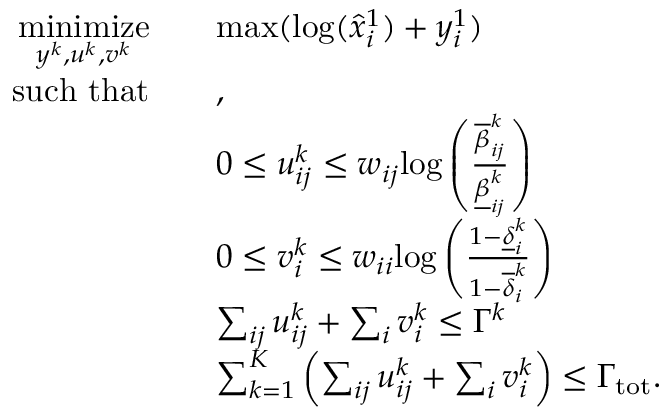<formula> <loc_0><loc_0><loc_500><loc_500>\begin{array} { r l } { \underset { y ^ { k } , u ^ { k } , v ^ { k } } { \min i m i z e } } & { \quad \max ( \log ( \hat { x } _ { i } ^ { 1 } ) + y _ { i } ^ { 1 } ) } \\ { s u c h t h a t } & { \quad , \quad } \\ & { \quad 0 \leq u _ { i j } ^ { k } \leq w _ { i j } \log \left ( \frac { \overline { \beta } _ { i j } ^ { k } } { \underline { \beta } _ { i j } ^ { k } } \right ) } \\ & { \quad 0 \leq v _ { i } ^ { k } \leq w _ { i i } \log \left ( \frac { 1 - \underline { \delta } _ { i } ^ { k } } { 1 - \overline { \delta } _ { i } ^ { k } } \right ) } \\ & { \quad \sum _ { i j } u _ { i j } ^ { k } + \sum _ { i } v _ { i } ^ { k } \leq \Gamma ^ { k } } \\ & { \quad \sum _ { k = 1 } ^ { K } \left ( \sum _ { i j } u _ { i j } ^ { k } + \sum _ { i } v _ { i } ^ { k } \right ) \leq \Gamma _ { t o t } . } \end{array}</formula> 